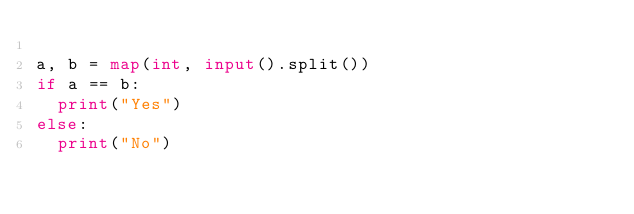Convert code to text. <code><loc_0><loc_0><loc_500><loc_500><_Python_>
a, b = map(int, input().split())
if a == b:
  print("Yes")
else:
  print("No")
</code> 